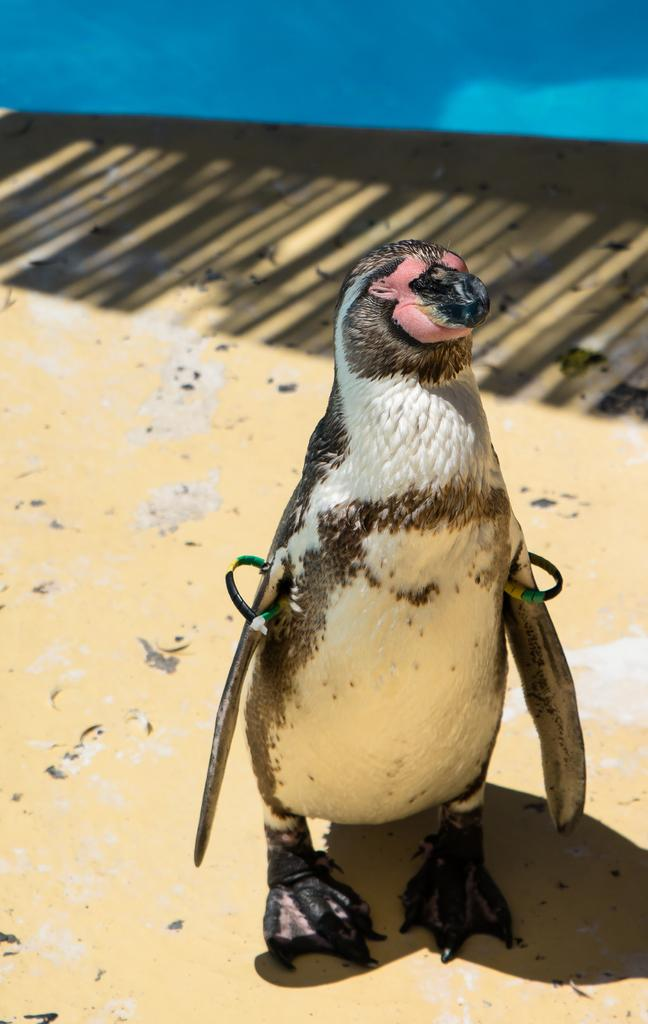What type of animal is in the image? There is a penguin in the image. What is the penguin standing on? The penguin is on a surface. What color is the background of the image? The background of the image is blue. How many children are holding milk in the image? There are no children or milk present in the image; it features a penguin on a surface with a blue background. What type of dogs can be seen playing with the penguin in the image? There are no dogs present in the image; it features a penguin on a surface with a blue background. 